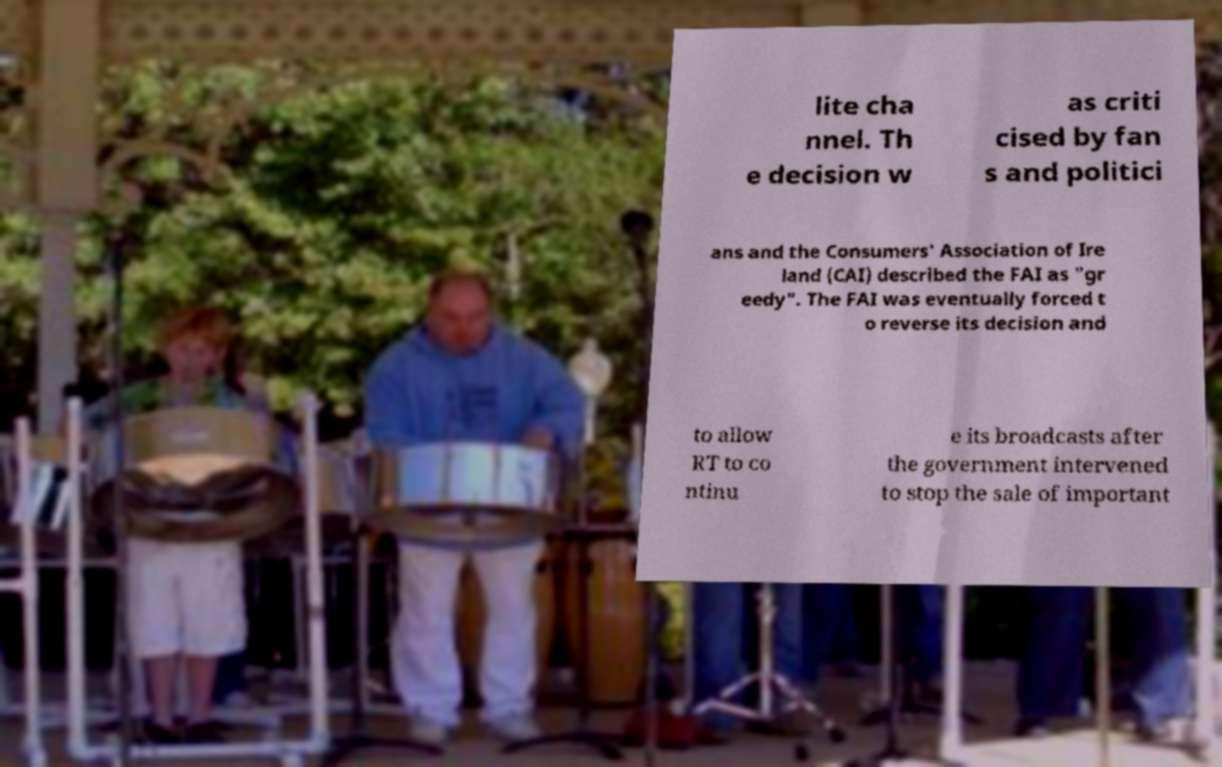There's text embedded in this image that I need extracted. Can you transcribe it verbatim? lite cha nnel. Th e decision w as criti cised by fan s and politici ans and the Consumers' Association of Ire land (CAI) described the FAI as "gr eedy". The FAI was eventually forced t o reverse its decision and to allow RT to co ntinu e its broadcasts after the government intervened to stop the sale of important 